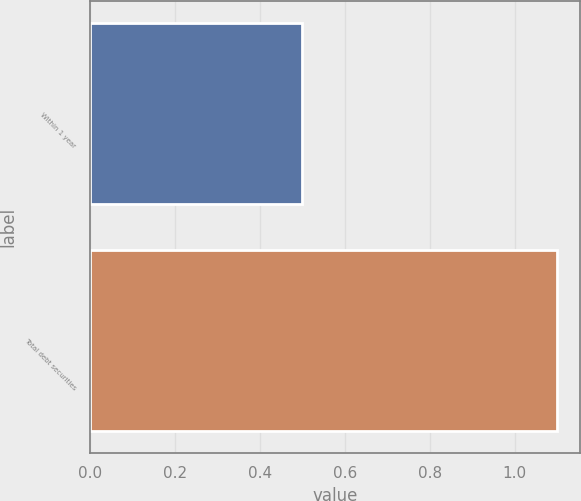<chart> <loc_0><loc_0><loc_500><loc_500><bar_chart><fcel>Within 1 year<fcel>Total debt securities<nl><fcel>0.5<fcel>1.1<nl></chart> 